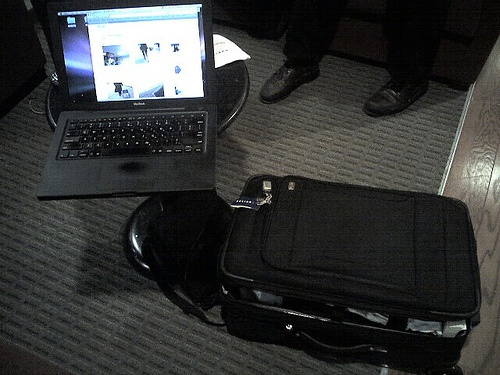Describe the objects in this image and their specific colors. I can see suitcase in black, gray, darkgray, and ivory tones, laptop in black, white, gray, and lightblue tones, couch in black and gray tones, people in black and gray tones, and backpack in black and gray tones in this image. 